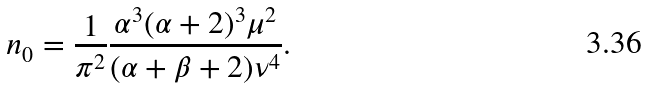<formula> <loc_0><loc_0><loc_500><loc_500>n _ { 0 } = \frac { 1 } { \pi ^ { 2 } } \frac { \alpha ^ { 3 } ( \alpha + 2 ) ^ { 3 } \mu ^ { 2 } } { ( \alpha + \beta + 2 ) \nu ^ { 4 } } .</formula> 